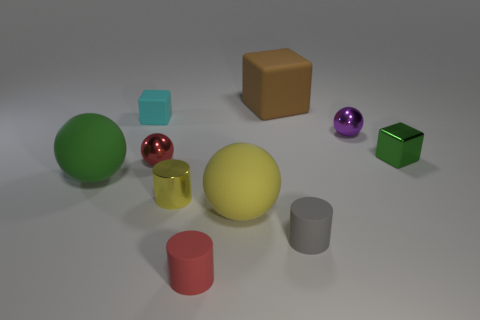What color is the small cylinder that is to the right of the big brown rubber block?
Offer a terse response. Gray. Does the large rubber sphere to the right of the red metallic ball have the same color as the shiny cylinder?
Keep it short and to the point. Yes. The yellow thing that is the same shape as the big green thing is what size?
Provide a succinct answer. Large. There is a red thing that is in front of the matte ball that is left of the red object that is behind the yellow matte ball; what is its material?
Offer a very short reply. Rubber. Are there more small rubber objects in front of the yellow metal object than spheres that are on the left side of the tiny red metallic ball?
Make the answer very short. Yes. Is the purple object the same size as the yellow ball?
Your answer should be compact. No. What color is the other rubber object that is the same shape as the brown rubber object?
Ensure brevity in your answer.  Cyan. How many large things have the same color as the tiny metallic cylinder?
Your answer should be compact. 1. Is the number of small cylinders that are in front of the gray rubber cylinder greater than the number of large purple matte cylinders?
Give a very brief answer. Yes. The rubber ball on the right side of the red thing on the left side of the tiny red matte cylinder is what color?
Keep it short and to the point. Yellow. 